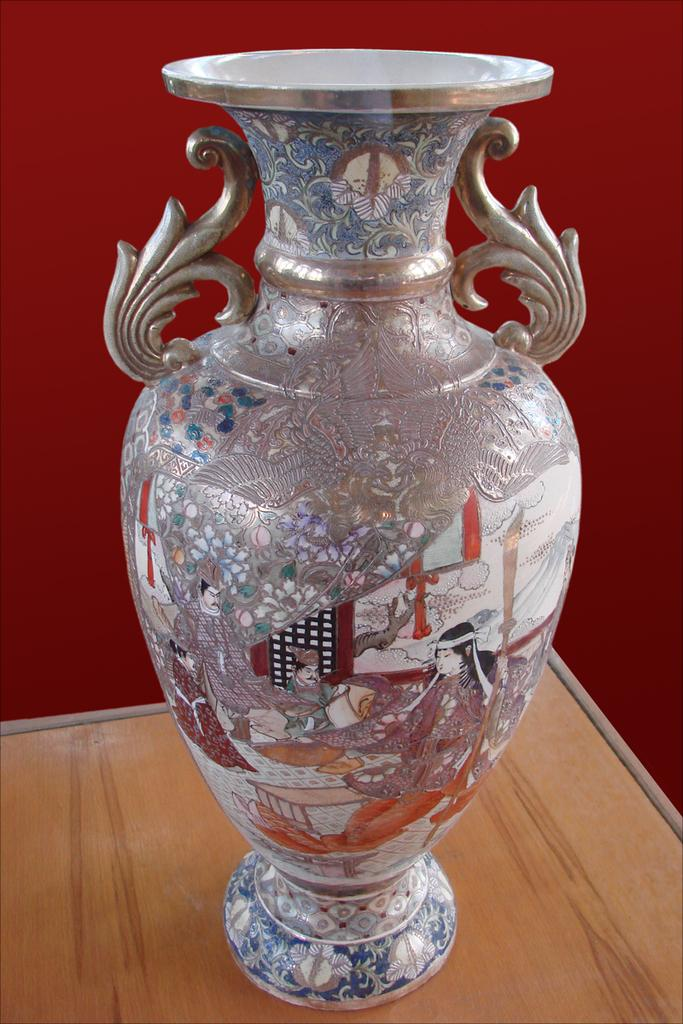What object is present in the image? There is a vase in the image. On what surface is the vase placed? The vase is on a wooden surface. What can be seen in the background of the image? There is a red color wall in the background of the image. What grade did the group receive on the card in the image? There is no card or grade present in the image. 